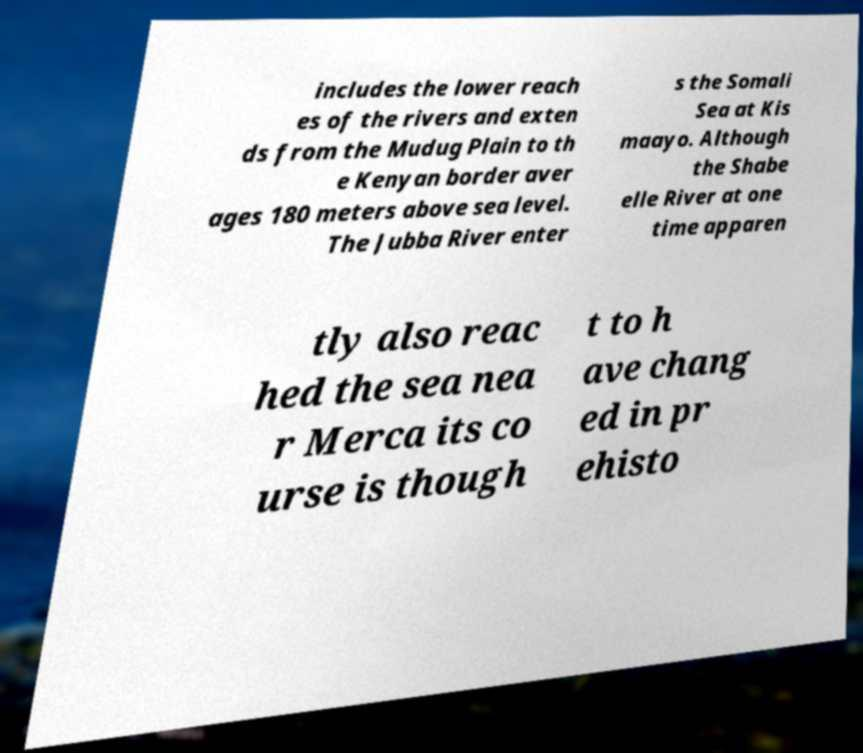Please read and relay the text visible in this image. What does it say? includes the lower reach es of the rivers and exten ds from the Mudug Plain to th e Kenyan border aver ages 180 meters above sea level. The Jubba River enter s the Somali Sea at Kis maayo. Although the Shabe elle River at one time apparen tly also reac hed the sea nea r Merca its co urse is though t to h ave chang ed in pr ehisto 